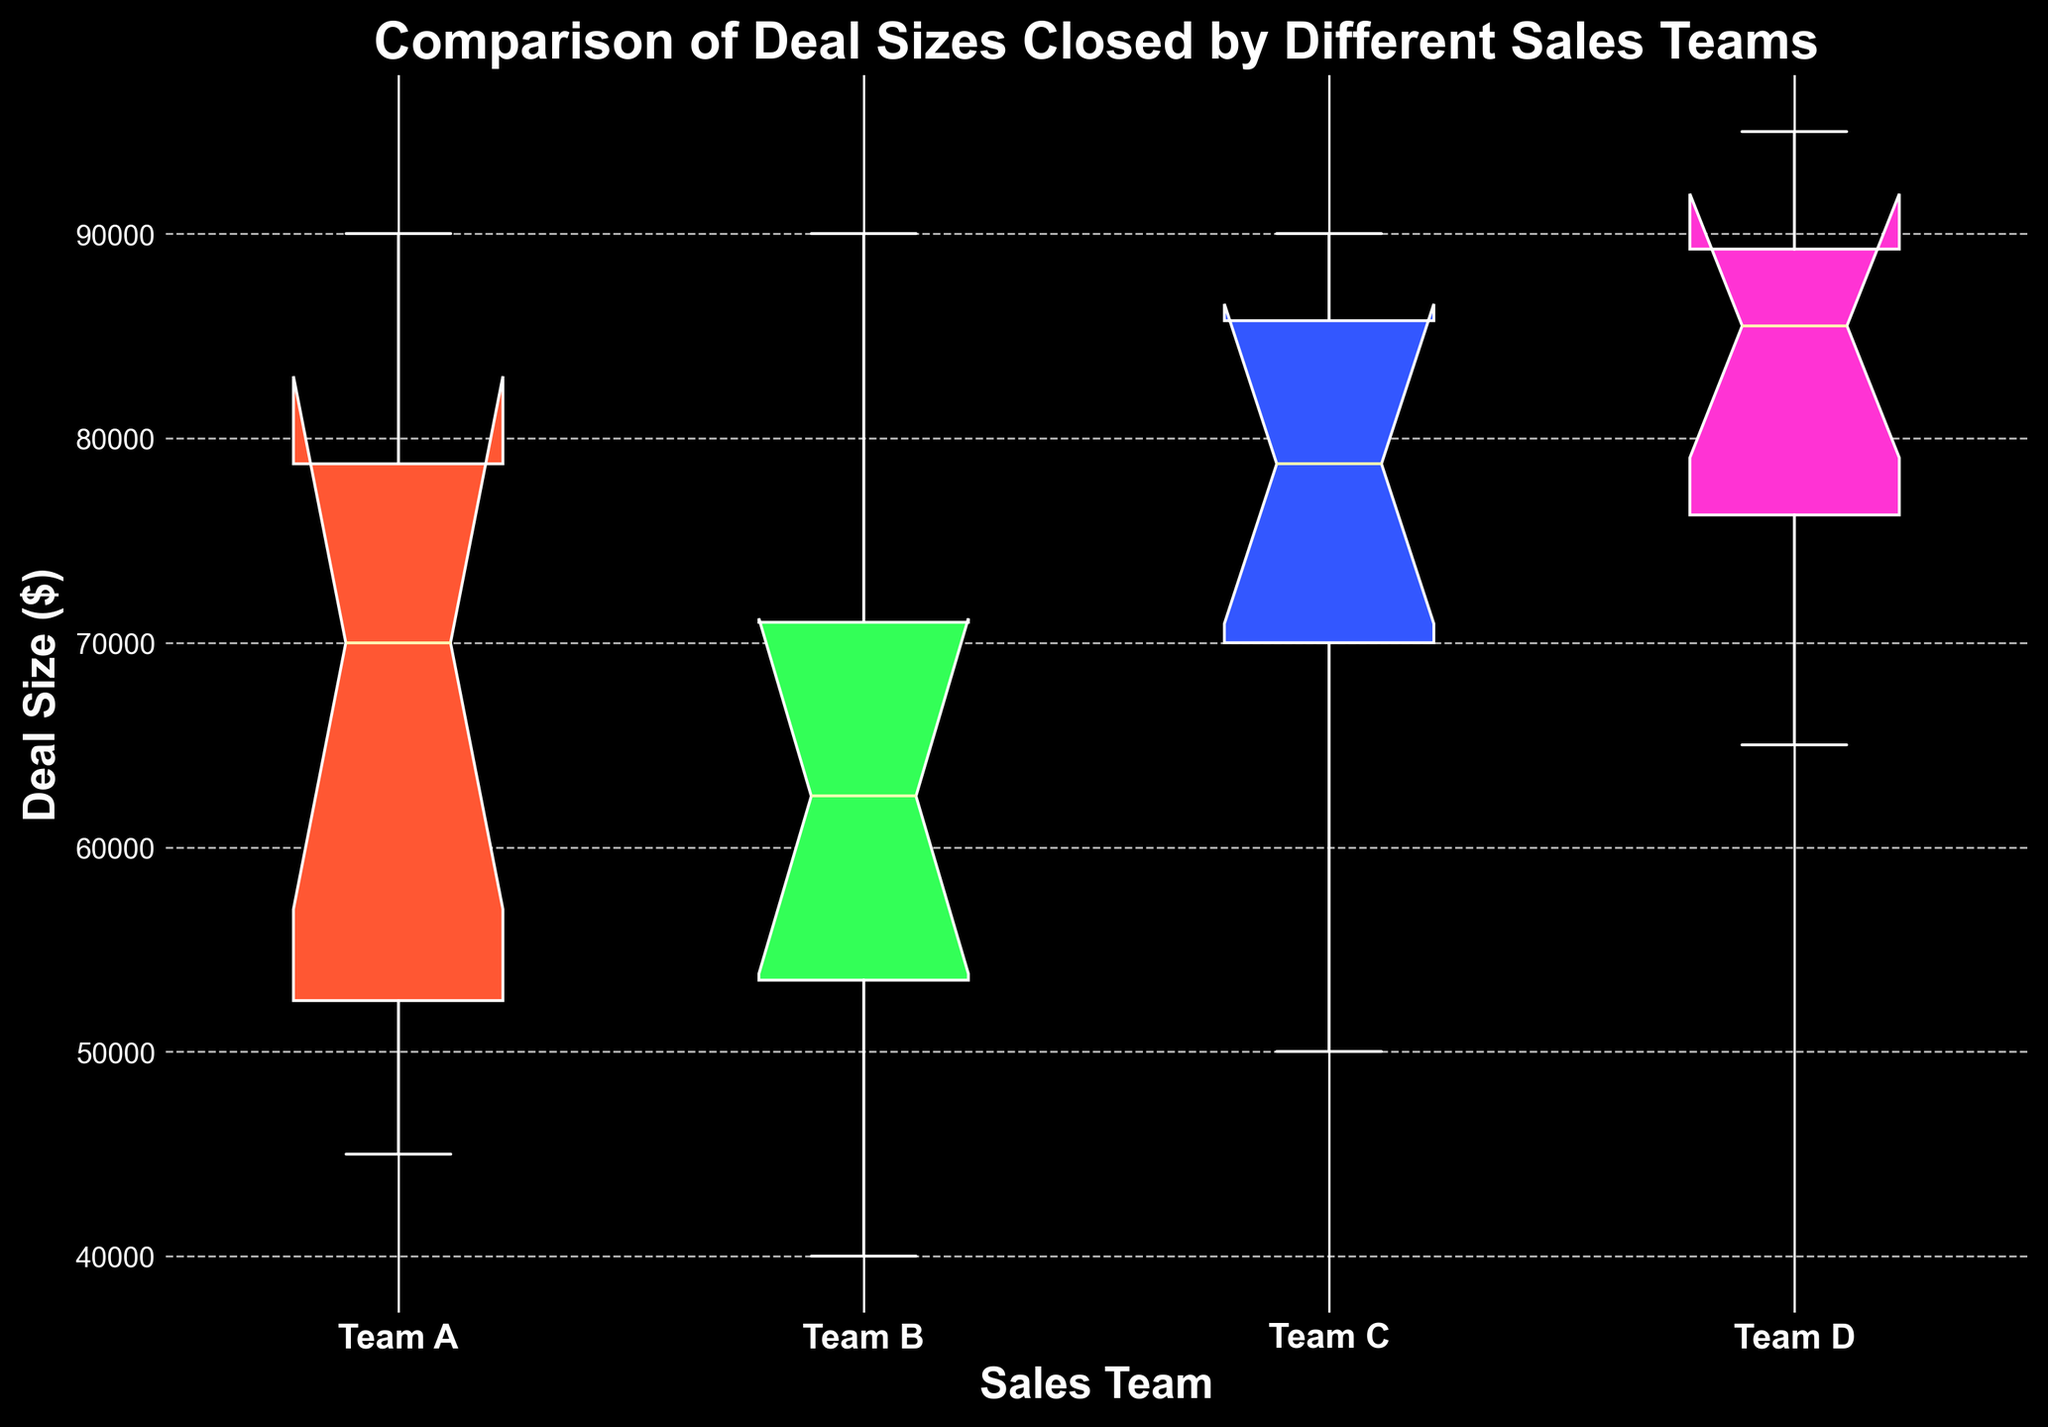What is the median deal size for Team A? The median is the middle value in the sorted list of deal sizes for Team A. In the figure, locate the horizontal line inside the box for Team A to find the median.
Answer: 70000 Which team closed the largest deal overall? Identify the highest whisker or spot for all the boxplots in the figure. Team D has the highest value at approximately 95000.
Answer: Team D How does the interquartile range (IQR) of Team B compare to that of Team C? The IQR is the range between the first quartile (Q1) and the third quartile (Q3), represented by the box's length. Compare the lengths of the boxes for Team B and Team C. Team C's box appears longer, indicating a larger IQR.
Answer: Team C has a larger IQR Which team has the smallest median deal size? Locate the boxes' median lines (horizontal lines within the boxes) for all teams. Team B's median line is the lowest.
Answer: Team B Is there a team with any outlier deal sizes? Look for any dots outside the whiskers on the boxplots, which indicate outliers. There are no dots, so no team has outliers.
Answer: No What is the median difference in deal sizes between Team C and Team D? Find the median lines inside the boxes for both Team C and Team D. Subtract Team C's median from Team D's median. Team D's median is approximately 86000, and Team C's median is 80000. 86000 - 80000 = 6000
Answer: 6000 Which team has the widest range of deal sizes? The range is the distance between the top and bottom whiskers. Team D has the widest range as its whiskers span from approximately 65000 to 95000.
Answer: Team D How do the 75th percentiles of Team A and Team C compare? The 75th percentile is the top edge of the box. Compare the top edges of the boxes for Team A and Team C. Team C's top edge is higher.
Answer: Team C's 75th percentile is higher Which team shows the greatest variability in deal sizes? Variability can be indicated by the length of the box (IQR) and the whiskers (total range). Team D's plot shows the largest variability as both the box and whiskers are the longest.
Answer: Team D 